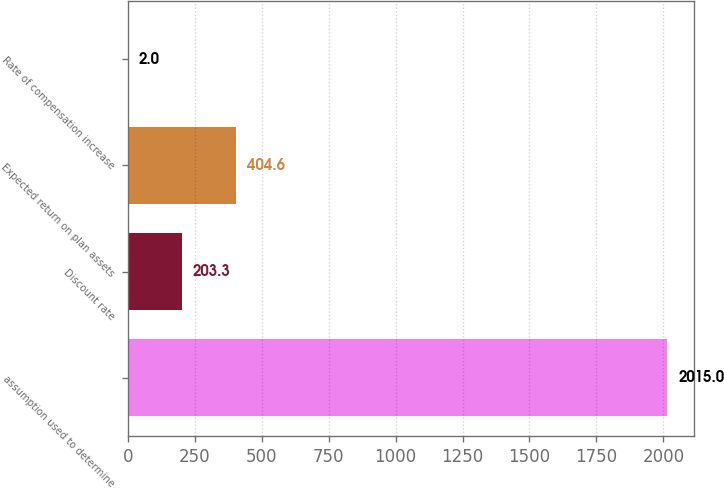Convert chart. <chart><loc_0><loc_0><loc_500><loc_500><bar_chart><fcel>assumption used to determine<fcel>Discount rate<fcel>Expected return on plan assets<fcel>Rate of compensation increase<nl><fcel>2015<fcel>203.3<fcel>404.6<fcel>2<nl></chart> 